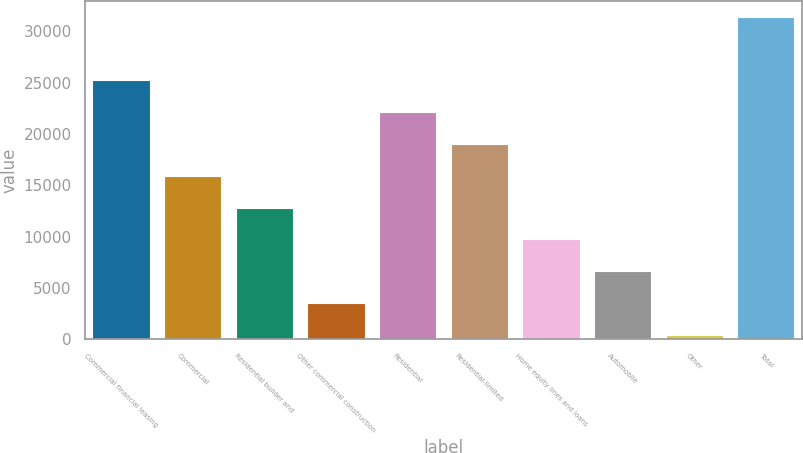Convert chart. <chart><loc_0><loc_0><loc_500><loc_500><bar_chart><fcel>Commercial financial leasing<fcel>Commercial<fcel>Residential builder and<fcel>Other commercial construction<fcel>Residential<fcel>Residential-limited<fcel>Home equity lines and loans<fcel>Automobile<fcel>Other<fcel>Total<nl><fcel>25205.6<fcel>15918.5<fcel>12822.8<fcel>3535.7<fcel>22109.9<fcel>19014.2<fcel>9727.1<fcel>6631.4<fcel>440<fcel>31397<nl></chart> 